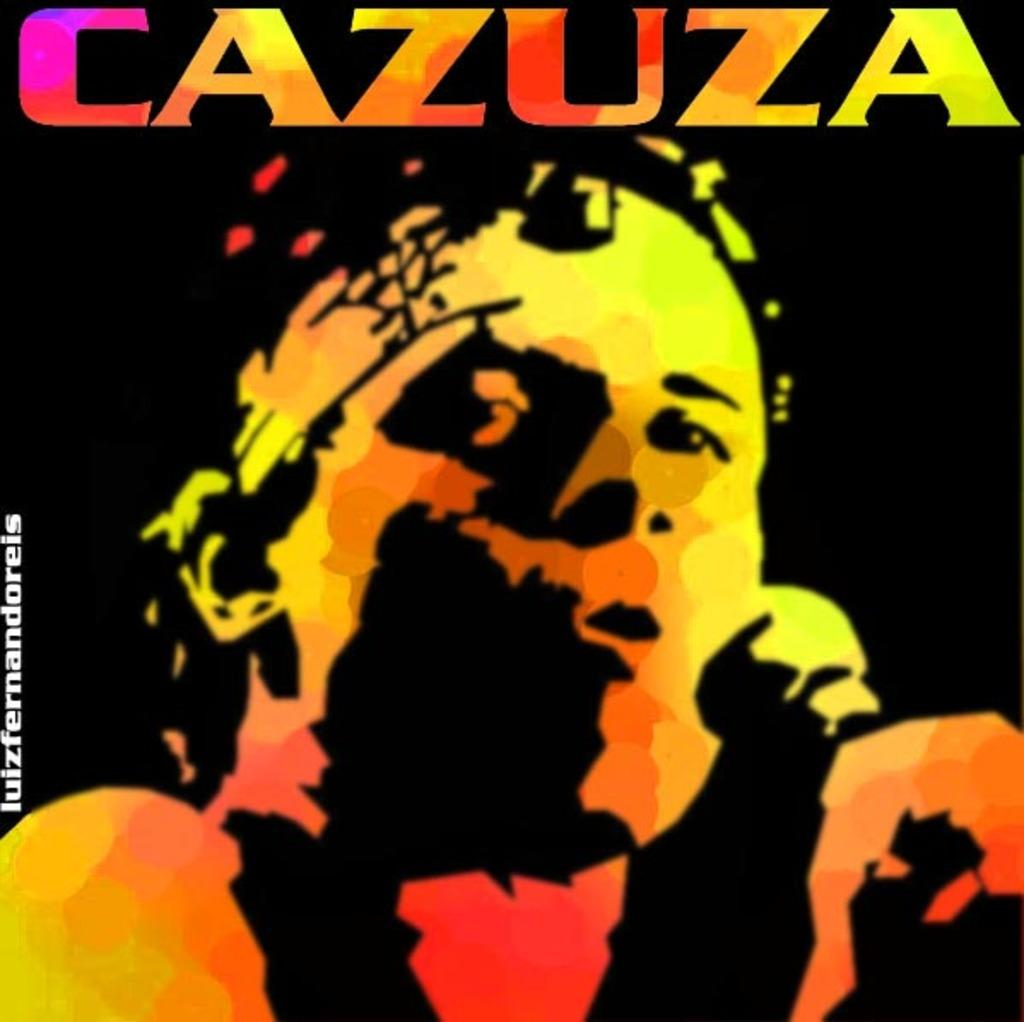<image>
Create a compact narrative representing the image presented. artwork that says the word 'cazuza' at the top 